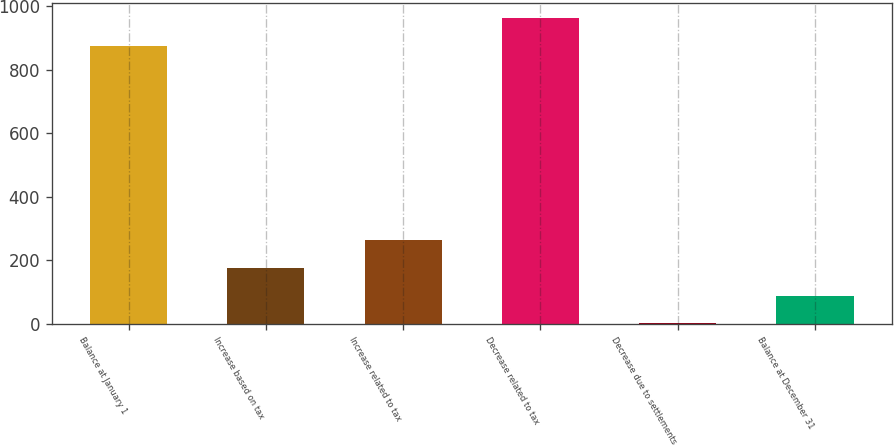Convert chart to OTSL. <chart><loc_0><loc_0><loc_500><loc_500><bar_chart><fcel>Balance at January 1<fcel>Increase based on tax<fcel>Increase related to tax<fcel>Decrease related to tax<fcel>Decrease due to settlements<fcel>Balance at December 31<nl><fcel>875<fcel>175.32<fcel>262.78<fcel>962.46<fcel>0.4<fcel>87.86<nl></chart> 